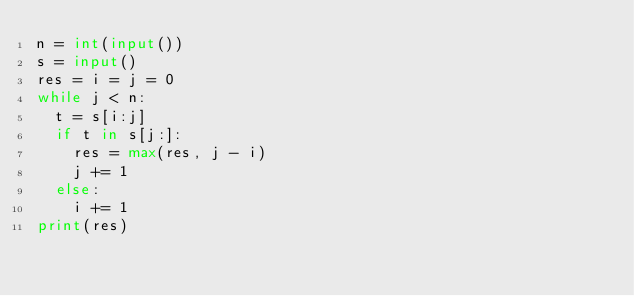<code> <loc_0><loc_0><loc_500><loc_500><_Python_>n = int(input())
s = input()
res = i = j = 0
while j < n:
  t = s[i:j]
  if t in s[j:]:
    res = max(res, j - i)
    j += 1
  else:
    i += 1
print(res)</code> 